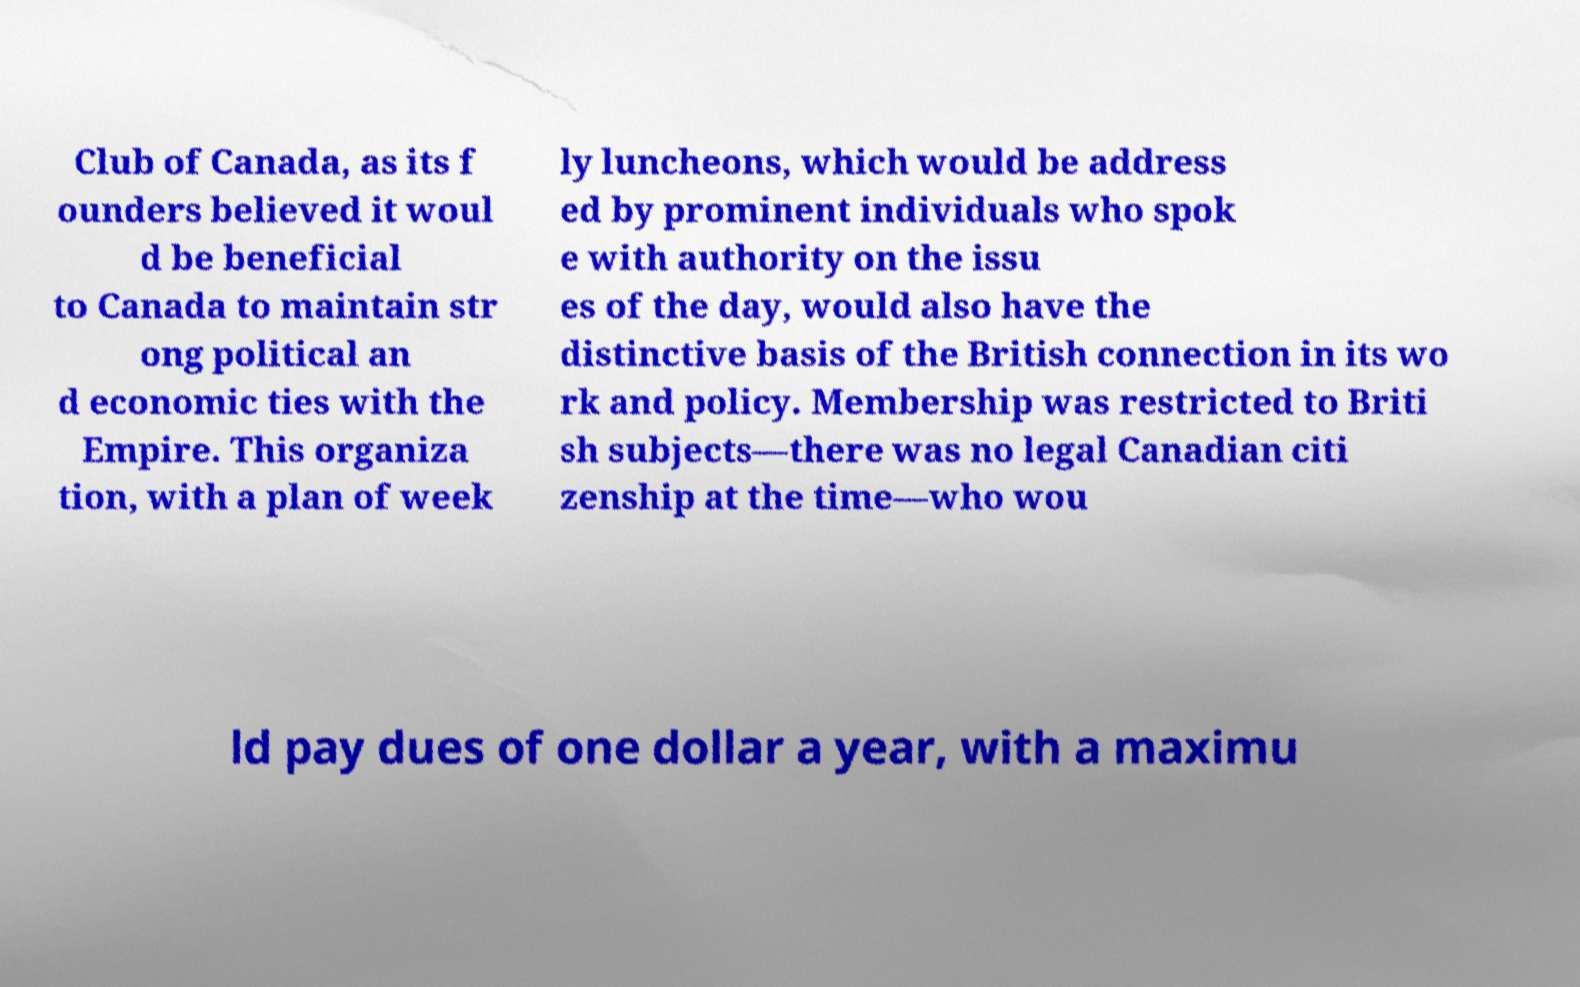Could you assist in decoding the text presented in this image and type it out clearly? Club of Canada, as its f ounders believed it woul d be beneficial to Canada to maintain str ong political an d economic ties with the Empire. This organiza tion, with a plan of week ly luncheons, which would be address ed by prominent individuals who spok e with authority on the issu es of the day, would also have the distinctive basis of the British connection in its wo rk and policy. Membership was restricted to Briti sh subjects—there was no legal Canadian citi zenship at the time—who wou ld pay dues of one dollar a year, with a maximu 